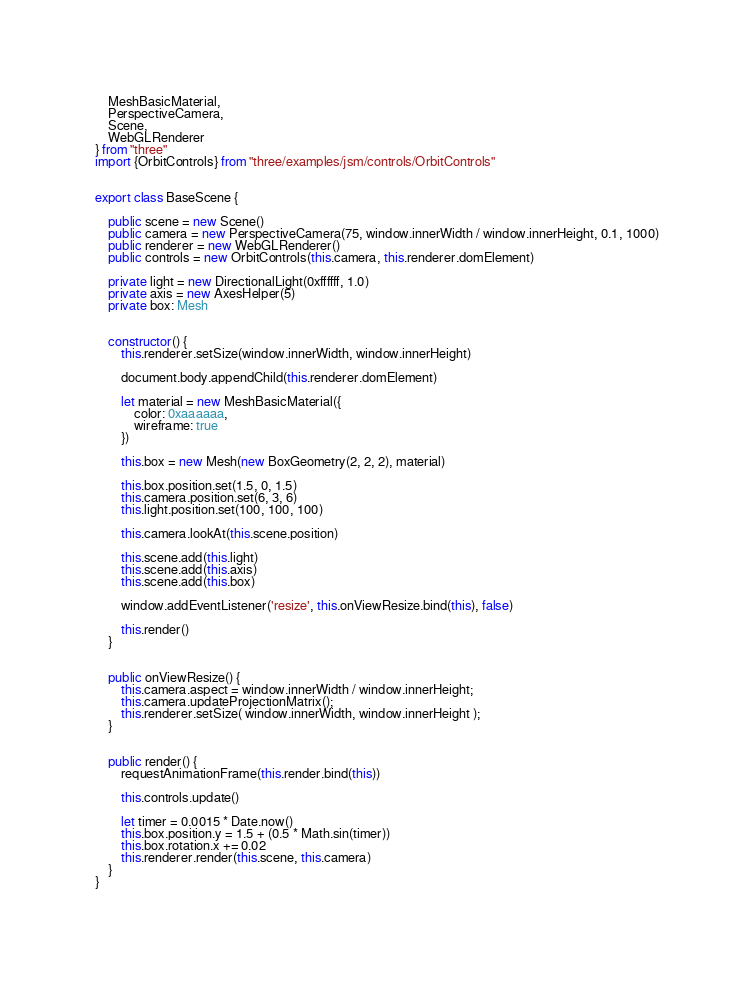<code> <loc_0><loc_0><loc_500><loc_500><_TypeScript_>    MeshBasicMaterial,
    PerspectiveCamera,
    Scene,
    WebGLRenderer
} from "three"
import {OrbitControls} from "three/examples/jsm/controls/OrbitControls"


export class BaseScene {

    public scene = new Scene()
    public camera = new PerspectiveCamera(75, window.innerWidth / window.innerHeight, 0.1, 1000)
    public renderer = new WebGLRenderer()
    public controls = new OrbitControls(this.camera, this.renderer.domElement)

    private light = new DirectionalLight(0xffffff, 1.0)
    private axis = new AxesHelper(5)
    private box: Mesh


    constructor() {
        this.renderer.setSize(window.innerWidth, window.innerHeight)

        document.body.appendChild(this.renderer.domElement)

        let material = new MeshBasicMaterial({
            color: 0xaaaaaa,
            wireframe: true
        })

        this.box = new Mesh(new BoxGeometry(2, 2, 2), material)

        this.box.position.set(1.5, 0, 1.5)
        this.camera.position.set(6, 3, 6)
        this.light.position.set(100, 100, 100)

        this.camera.lookAt(this.scene.position)

        this.scene.add(this.light)
        this.scene.add(this.axis)
        this.scene.add(this.box)

        window.addEventListener('resize', this.onViewResize.bind(this), false)

        this.render()
    }


    public onViewResize() {
        this.camera.aspect = window.innerWidth / window.innerHeight;
        this.camera.updateProjectionMatrix();
        this.renderer.setSize( window.innerWidth, window.innerHeight );
    }


    public render() {
        requestAnimationFrame(this.render.bind(this))

        this.controls.update()

        let timer = 0.0015 * Date.now()
        this.box.position.y = 1.5 + (0.5 * Math.sin(timer))
        this.box.rotation.x += 0.02
        this.renderer.render(this.scene, this.camera)
    }
}



</code> 